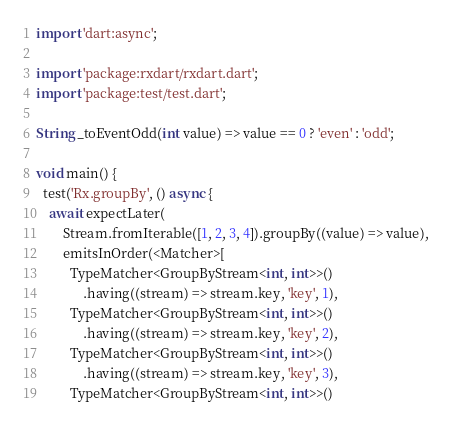Convert code to text. <code><loc_0><loc_0><loc_500><loc_500><_Dart_>import 'dart:async';

import 'package:rxdart/rxdart.dart';
import 'package:test/test.dart';

String _toEventOdd(int value) => value == 0 ? 'even' : 'odd';

void main() {
  test('Rx.groupBy', () async {
    await expectLater(
        Stream.fromIterable([1, 2, 3, 4]).groupBy((value) => value),
        emitsInOrder(<Matcher>[
          TypeMatcher<GroupByStream<int, int>>()
              .having((stream) => stream.key, 'key', 1),
          TypeMatcher<GroupByStream<int, int>>()
              .having((stream) => stream.key, 'key', 2),
          TypeMatcher<GroupByStream<int, int>>()
              .having((stream) => stream.key, 'key', 3),
          TypeMatcher<GroupByStream<int, int>>()</code> 